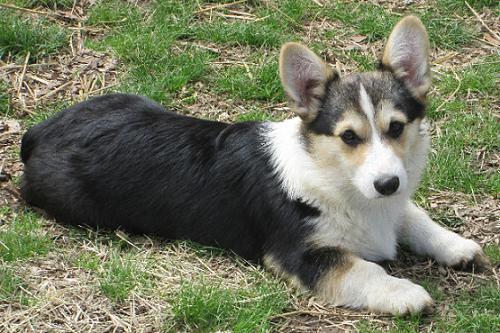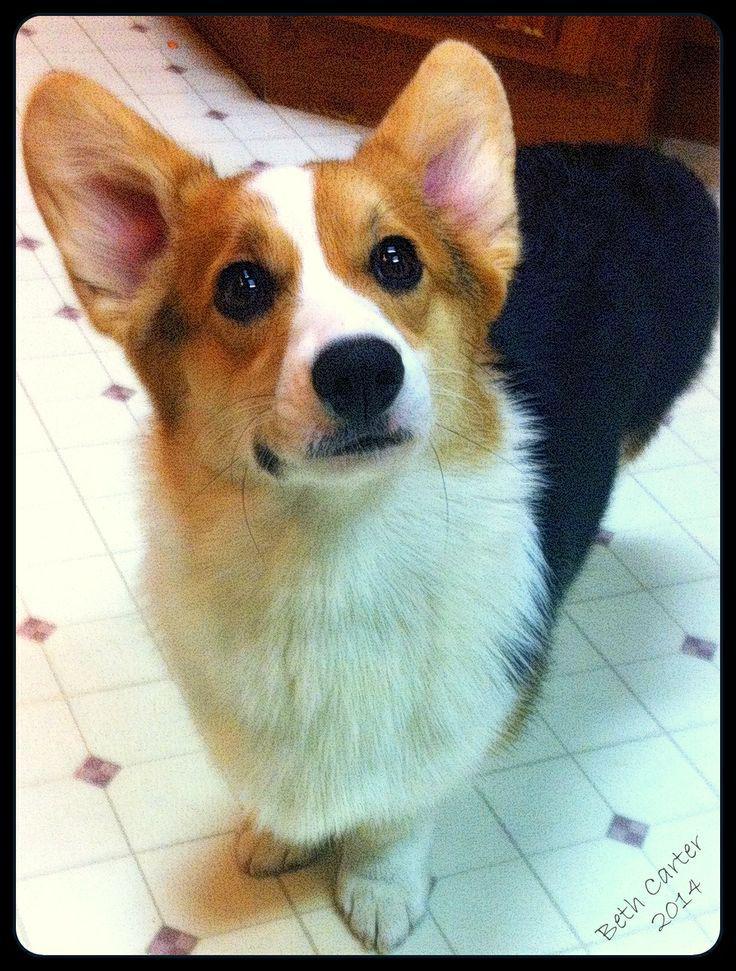The first image is the image on the left, the second image is the image on the right. Given the left and right images, does the statement "An image shows a corgi dog without a leash, standing on all fours and looking upward at the camera." hold true? Answer yes or no. Yes. The first image is the image on the left, the second image is the image on the right. For the images displayed, is the sentence "At least one dog's tongue is hanging out of its mouth." factually correct? Answer yes or no. No. 